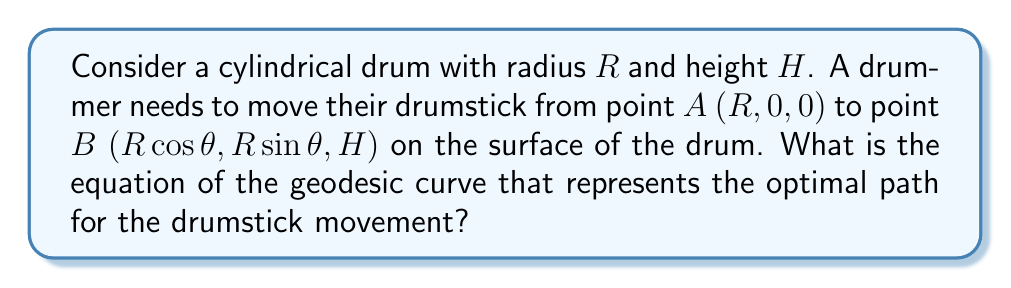Give your solution to this math problem. To find the geodesic on a cylindrical surface, we follow these steps:

1) First, we parameterize the cylinder. Let $\mathbf{r}(u,v)$ be a point on the cylinder:
   $$\mathbf{r}(u,v) = (R\cos u, R\sin u, v)$$
   where $0 \leq u < 2\pi$ and $0 \leq v \leq H$.

2) The geodesic equation on a surface is given by:
   $$\frac{d^2x^i}{ds^2} + \Gamma^i_{jk}\frac{dx^j}{ds}\frac{dx^k}{ds} = 0$$
   where $\Gamma^i_{jk}$ are the Christoffel symbols and $s$ is the arc length parameter.

3) For a cylinder, due to its simple geometry, the geodesic equation simplifies to:
   $$\frac{d^2u}{ds^2} = 0 \quad \text{and} \quad \frac{d^2v}{ds^2} = 0$$

4) The solutions to these equations are:
   $$u = as + b \quad \text{and} \quad v = cs + d$$
   where $a$, $b$, $c$, and $d$ are constants.

5) These equations represent a helix on the cylinder. We can eliminate the parameter $s$ to get:
   $$v = \frac{c}{a}(u - b) + d$$

6) Now, we need to find the constants using our boundary conditions:
   At $s = 0$: $u = 0$, $v = 0$ (point A)
   At $s = 1$: $u = \theta$, $v = H$ (point B)

7) Applying these conditions:
   $$b = 0, \quad a = \theta, \quad c = H, \quad d = 0$$

8) Substituting back, we get the equation of the geodesic:
   $$v = \frac{H}{\theta}u$$

This equation represents a straight line when the cylinder is "unrolled" onto a plane.
Answer: $v = \frac{H}{\theta}u$ 